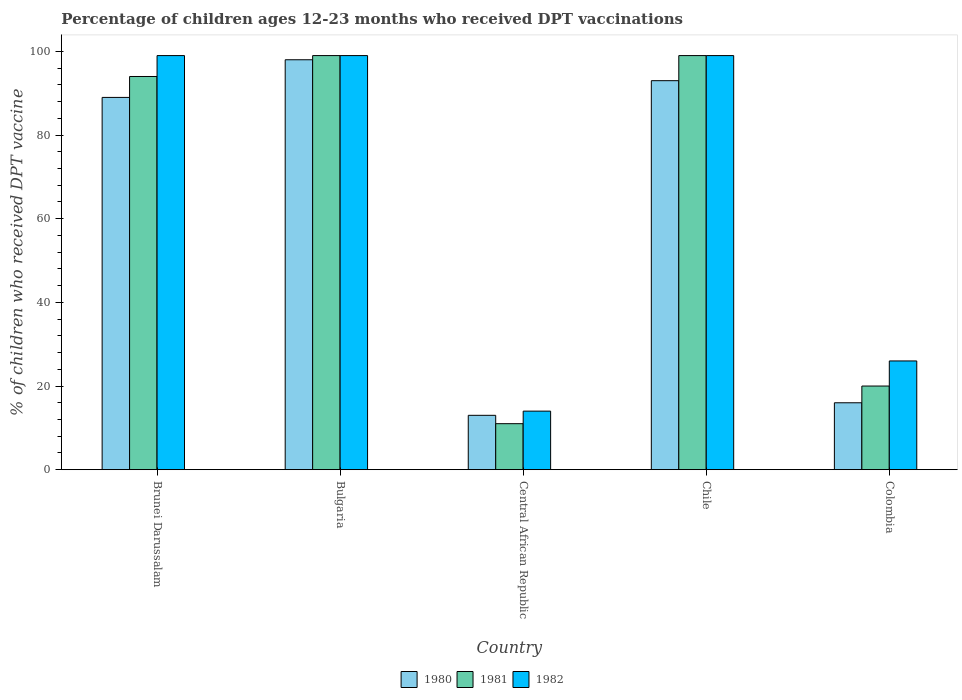How many different coloured bars are there?
Ensure brevity in your answer.  3. How many groups of bars are there?
Ensure brevity in your answer.  5. What is the percentage of children who received DPT vaccination in 1982 in Central African Republic?
Offer a terse response. 14. Across all countries, what is the maximum percentage of children who received DPT vaccination in 1980?
Your answer should be compact. 98. In which country was the percentage of children who received DPT vaccination in 1981 maximum?
Ensure brevity in your answer.  Bulgaria. In which country was the percentage of children who received DPT vaccination in 1982 minimum?
Offer a very short reply. Central African Republic. What is the total percentage of children who received DPT vaccination in 1980 in the graph?
Your response must be concise. 309. What is the difference between the percentage of children who received DPT vaccination in 1981 in Brunei Darussalam and that in Chile?
Keep it short and to the point. -5. What is the difference between the percentage of children who received DPT vaccination in 1981 in Colombia and the percentage of children who received DPT vaccination in 1980 in Bulgaria?
Offer a very short reply. -78. What is the average percentage of children who received DPT vaccination in 1982 per country?
Your answer should be compact. 67.4. What is the difference between the percentage of children who received DPT vaccination of/in 1980 and percentage of children who received DPT vaccination of/in 1982 in Colombia?
Provide a short and direct response. -10. What is the ratio of the percentage of children who received DPT vaccination in 1982 in Brunei Darussalam to that in Bulgaria?
Your response must be concise. 1. Is the difference between the percentage of children who received DPT vaccination in 1980 in Brunei Darussalam and Chile greater than the difference between the percentage of children who received DPT vaccination in 1982 in Brunei Darussalam and Chile?
Your response must be concise. No. What is the difference between the highest and the second highest percentage of children who received DPT vaccination in 1980?
Give a very brief answer. -9. Is the sum of the percentage of children who received DPT vaccination in 1982 in Brunei Darussalam and Chile greater than the maximum percentage of children who received DPT vaccination in 1981 across all countries?
Your response must be concise. Yes. What does the 2nd bar from the left in Central African Republic represents?
Offer a terse response. 1981. Are all the bars in the graph horizontal?
Provide a short and direct response. No. How many countries are there in the graph?
Provide a succinct answer. 5. What is the difference between two consecutive major ticks on the Y-axis?
Your response must be concise. 20. Are the values on the major ticks of Y-axis written in scientific E-notation?
Keep it short and to the point. No. Where does the legend appear in the graph?
Provide a succinct answer. Bottom center. What is the title of the graph?
Provide a succinct answer. Percentage of children ages 12-23 months who received DPT vaccinations. What is the label or title of the Y-axis?
Provide a short and direct response. % of children who received DPT vaccine. What is the % of children who received DPT vaccine of 1980 in Brunei Darussalam?
Offer a very short reply. 89. What is the % of children who received DPT vaccine of 1981 in Brunei Darussalam?
Offer a terse response. 94. What is the % of children who received DPT vaccine of 1980 in Bulgaria?
Keep it short and to the point. 98. What is the % of children who received DPT vaccine of 1982 in Bulgaria?
Provide a short and direct response. 99. What is the % of children who received DPT vaccine of 1980 in Central African Republic?
Provide a succinct answer. 13. What is the % of children who received DPT vaccine in 1982 in Central African Republic?
Provide a short and direct response. 14. What is the % of children who received DPT vaccine in 1980 in Chile?
Give a very brief answer. 93. What is the % of children who received DPT vaccine in 1981 in Chile?
Offer a terse response. 99. What is the % of children who received DPT vaccine of 1980 in Colombia?
Give a very brief answer. 16. Across all countries, what is the maximum % of children who received DPT vaccine in 1980?
Make the answer very short. 98. Across all countries, what is the maximum % of children who received DPT vaccine in 1982?
Give a very brief answer. 99. Across all countries, what is the minimum % of children who received DPT vaccine in 1980?
Ensure brevity in your answer.  13. Across all countries, what is the minimum % of children who received DPT vaccine of 1982?
Offer a terse response. 14. What is the total % of children who received DPT vaccine in 1980 in the graph?
Your answer should be compact. 309. What is the total % of children who received DPT vaccine of 1981 in the graph?
Make the answer very short. 323. What is the total % of children who received DPT vaccine of 1982 in the graph?
Keep it short and to the point. 337. What is the difference between the % of children who received DPT vaccine of 1980 in Brunei Darussalam and that in Bulgaria?
Offer a terse response. -9. What is the difference between the % of children who received DPT vaccine in 1982 in Brunei Darussalam and that in Bulgaria?
Offer a very short reply. 0. What is the difference between the % of children who received DPT vaccine of 1980 in Brunei Darussalam and that in Chile?
Provide a short and direct response. -4. What is the difference between the % of children who received DPT vaccine of 1980 in Brunei Darussalam and that in Colombia?
Make the answer very short. 73. What is the difference between the % of children who received DPT vaccine of 1981 in Brunei Darussalam and that in Colombia?
Ensure brevity in your answer.  74. What is the difference between the % of children who received DPT vaccine of 1980 in Bulgaria and that in Central African Republic?
Provide a short and direct response. 85. What is the difference between the % of children who received DPT vaccine of 1982 in Bulgaria and that in Chile?
Your response must be concise. 0. What is the difference between the % of children who received DPT vaccine of 1981 in Bulgaria and that in Colombia?
Make the answer very short. 79. What is the difference between the % of children who received DPT vaccine of 1980 in Central African Republic and that in Chile?
Your response must be concise. -80. What is the difference between the % of children who received DPT vaccine of 1981 in Central African Republic and that in Chile?
Ensure brevity in your answer.  -88. What is the difference between the % of children who received DPT vaccine of 1982 in Central African Republic and that in Chile?
Provide a short and direct response. -85. What is the difference between the % of children who received DPT vaccine in 1980 in Chile and that in Colombia?
Ensure brevity in your answer.  77. What is the difference between the % of children who received DPT vaccine of 1981 in Chile and that in Colombia?
Keep it short and to the point. 79. What is the difference between the % of children who received DPT vaccine of 1982 in Chile and that in Colombia?
Provide a succinct answer. 73. What is the difference between the % of children who received DPT vaccine in 1980 in Brunei Darussalam and the % of children who received DPT vaccine in 1981 in Bulgaria?
Keep it short and to the point. -10. What is the difference between the % of children who received DPT vaccine of 1980 in Brunei Darussalam and the % of children who received DPT vaccine of 1982 in Bulgaria?
Give a very brief answer. -10. What is the difference between the % of children who received DPT vaccine in 1981 in Brunei Darussalam and the % of children who received DPT vaccine in 1982 in Bulgaria?
Ensure brevity in your answer.  -5. What is the difference between the % of children who received DPT vaccine in 1980 in Brunei Darussalam and the % of children who received DPT vaccine in 1982 in Central African Republic?
Offer a terse response. 75. What is the difference between the % of children who received DPT vaccine in 1981 in Brunei Darussalam and the % of children who received DPT vaccine in 1982 in Central African Republic?
Your answer should be compact. 80. What is the difference between the % of children who received DPT vaccine in 1980 in Brunei Darussalam and the % of children who received DPT vaccine in 1981 in Colombia?
Keep it short and to the point. 69. What is the difference between the % of children who received DPT vaccine of 1980 in Brunei Darussalam and the % of children who received DPT vaccine of 1982 in Colombia?
Your response must be concise. 63. What is the difference between the % of children who received DPT vaccine in 1981 in Brunei Darussalam and the % of children who received DPT vaccine in 1982 in Colombia?
Your answer should be compact. 68. What is the difference between the % of children who received DPT vaccine in 1980 in Bulgaria and the % of children who received DPT vaccine in 1981 in Chile?
Offer a terse response. -1. What is the difference between the % of children who received DPT vaccine in 1981 in Bulgaria and the % of children who received DPT vaccine in 1982 in Chile?
Give a very brief answer. 0. What is the difference between the % of children who received DPT vaccine in 1980 in Bulgaria and the % of children who received DPT vaccine in 1982 in Colombia?
Offer a very short reply. 72. What is the difference between the % of children who received DPT vaccine in 1980 in Central African Republic and the % of children who received DPT vaccine in 1981 in Chile?
Offer a terse response. -86. What is the difference between the % of children who received DPT vaccine in 1980 in Central African Republic and the % of children who received DPT vaccine in 1982 in Chile?
Provide a succinct answer. -86. What is the difference between the % of children who received DPT vaccine of 1981 in Central African Republic and the % of children who received DPT vaccine of 1982 in Chile?
Give a very brief answer. -88. What is the difference between the % of children who received DPT vaccine of 1981 in Chile and the % of children who received DPT vaccine of 1982 in Colombia?
Provide a succinct answer. 73. What is the average % of children who received DPT vaccine in 1980 per country?
Keep it short and to the point. 61.8. What is the average % of children who received DPT vaccine in 1981 per country?
Give a very brief answer. 64.6. What is the average % of children who received DPT vaccine of 1982 per country?
Make the answer very short. 67.4. What is the difference between the % of children who received DPT vaccine in 1980 and % of children who received DPT vaccine in 1982 in Brunei Darussalam?
Make the answer very short. -10. What is the difference between the % of children who received DPT vaccine in 1981 and % of children who received DPT vaccine in 1982 in Brunei Darussalam?
Offer a very short reply. -5. What is the difference between the % of children who received DPT vaccine of 1980 and % of children who received DPT vaccine of 1981 in Central African Republic?
Provide a short and direct response. 2. What is the difference between the % of children who received DPT vaccine of 1980 and % of children who received DPT vaccine of 1982 in Central African Republic?
Provide a short and direct response. -1. What is the difference between the % of children who received DPT vaccine of 1981 and % of children who received DPT vaccine of 1982 in Central African Republic?
Offer a terse response. -3. What is the difference between the % of children who received DPT vaccine in 1980 and % of children who received DPT vaccine in 1982 in Colombia?
Provide a short and direct response. -10. What is the difference between the % of children who received DPT vaccine in 1981 and % of children who received DPT vaccine in 1982 in Colombia?
Make the answer very short. -6. What is the ratio of the % of children who received DPT vaccine in 1980 in Brunei Darussalam to that in Bulgaria?
Ensure brevity in your answer.  0.91. What is the ratio of the % of children who received DPT vaccine in 1981 in Brunei Darussalam to that in Bulgaria?
Offer a terse response. 0.95. What is the ratio of the % of children who received DPT vaccine in 1980 in Brunei Darussalam to that in Central African Republic?
Offer a terse response. 6.85. What is the ratio of the % of children who received DPT vaccine in 1981 in Brunei Darussalam to that in Central African Republic?
Offer a terse response. 8.55. What is the ratio of the % of children who received DPT vaccine in 1982 in Brunei Darussalam to that in Central African Republic?
Offer a terse response. 7.07. What is the ratio of the % of children who received DPT vaccine of 1981 in Brunei Darussalam to that in Chile?
Offer a terse response. 0.95. What is the ratio of the % of children who received DPT vaccine of 1982 in Brunei Darussalam to that in Chile?
Your response must be concise. 1. What is the ratio of the % of children who received DPT vaccine in 1980 in Brunei Darussalam to that in Colombia?
Your answer should be very brief. 5.56. What is the ratio of the % of children who received DPT vaccine in 1981 in Brunei Darussalam to that in Colombia?
Provide a succinct answer. 4.7. What is the ratio of the % of children who received DPT vaccine of 1982 in Brunei Darussalam to that in Colombia?
Your response must be concise. 3.81. What is the ratio of the % of children who received DPT vaccine of 1980 in Bulgaria to that in Central African Republic?
Offer a terse response. 7.54. What is the ratio of the % of children who received DPT vaccine in 1982 in Bulgaria to that in Central African Republic?
Give a very brief answer. 7.07. What is the ratio of the % of children who received DPT vaccine of 1980 in Bulgaria to that in Chile?
Ensure brevity in your answer.  1.05. What is the ratio of the % of children who received DPT vaccine in 1981 in Bulgaria to that in Chile?
Provide a succinct answer. 1. What is the ratio of the % of children who received DPT vaccine in 1982 in Bulgaria to that in Chile?
Give a very brief answer. 1. What is the ratio of the % of children who received DPT vaccine of 1980 in Bulgaria to that in Colombia?
Offer a very short reply. 6.12. What is the ratio of the % of children who received DPT vaccine in 1981 in Bulgaria to that in Colombia?
Ensure brevity in your answer.  4.95. What is the ratio of the % of children who received DPT vaccine in 1982 in Bulgaria to that in Colombia?
Ensure brevity in your answer.  3.81. What is the ratio of the % of children who received DPT vaccine of 1980 in Central African Republic to that in Chile?
Offer a very short reply. 0.14. What is the ratio of the % of children who received DPT vaccine in 1982 in Central African Republic to that in Chile?
Offer a terse response. 0.14. What is the ratio of the % of children who received DPT vaccine of 1980 in Central African Republic to that in Colombia?
Offer a very short reply. 0.81. What is the ratio of the % of children who received DPT vaccine in 1981 in Central African Republic to that in Colombia?
Give a very brief answer. 0.55. What is the ratio of the % of children who received DPT vaccine of 1982 in Central African Republic to that in Colombia?
Make the answer very short. 0.54. What is the ratio of the % of children who received DPT vaccine in 1980 in Chile to that in Colombia?
Provide a succinct answer. 5.81. What is the ratio of the % of children who received DPT vaccine of 1981 in Chile to that in Colombia?
Offer a very short reply. 4.95. What is the ratio of the % of children who received DPT vaccine in 1982 in Chile to that in Colombia?
Provide a succinct answer. 3.81. What is the difference between the highest and the second highest % of children who received DPT vaccine of 1981?
Offer a very short reply. 0. What is the difference between the highest and the lowest % of children who received DPT vaccine of 1980?
Make the answer very short. 85. What is the difference between the highest and the lowest % of children who received DPT vaccine of 1981?
Your answer should be very brief. 88. What is the difference between the highest and the lowest % of children who received DPT vaccine in 1982?
Provide a short and direct response. 85. 